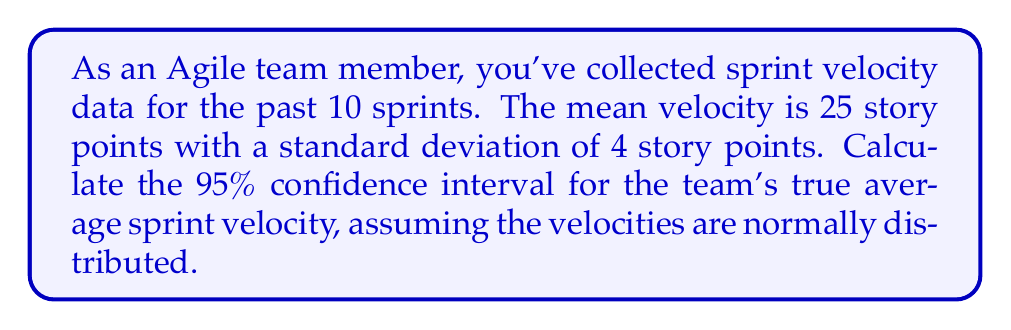Give your solution to this math problem. To calculate the confidence interval for the sprint velocity, we'll follow these steps:

1. Identify the given information:
   - Sample size (n) = 10 sprints
   - Sample mean (x̄) = 25 story points
   - Sample standard deviation (s) = 4 story points
   - Confidence level = 95%

2. Determine the t-value:
   For a 95% confidence interval with 9 degrees of freedom (n-1), the t-value is approximately 2.262 (from t-distribution table).

3. Calculate the margin of error:
   Margin of error = t * (s / √n)
   $$ \text{Margin of error} = 2.262 \cdot \frac{4}{\sqrt{10}} = 2.262 \cdot 1.265 = 2.86 $$

4. Calculate the confidence interval:
   Lower bound = x̄ - margin of error
   Upper bound = x̄ + margin of error

   $$ \text{Lower bound} = 25 - 2.86 = 22.14 $$
   $$ \text{Upper bound} = 25 + 2.86 = 27.86 $$

5. Round the results to two decimal places:
   Confidence interval: (22.14, 27.86)

Therefore, we can be 95% confident that the true average sprint velocity for the team falls between 22.14 and 27.86 story points.
Answer: (22.14, 27.86) story points 